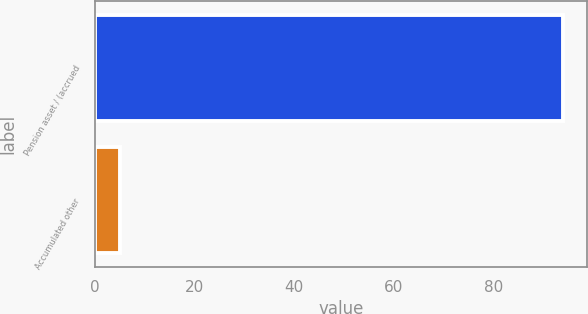<chart> <loc_0><loc_0><loc_500><loc_500><bar_chart><fcel>Pension asset / (accrued<fcel>Accumulated other<nl><fcel>94<fcel>5<nl></chart> 